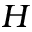<formula> <loc_0><loc_0><loc_500><loc_500>H</formula> 